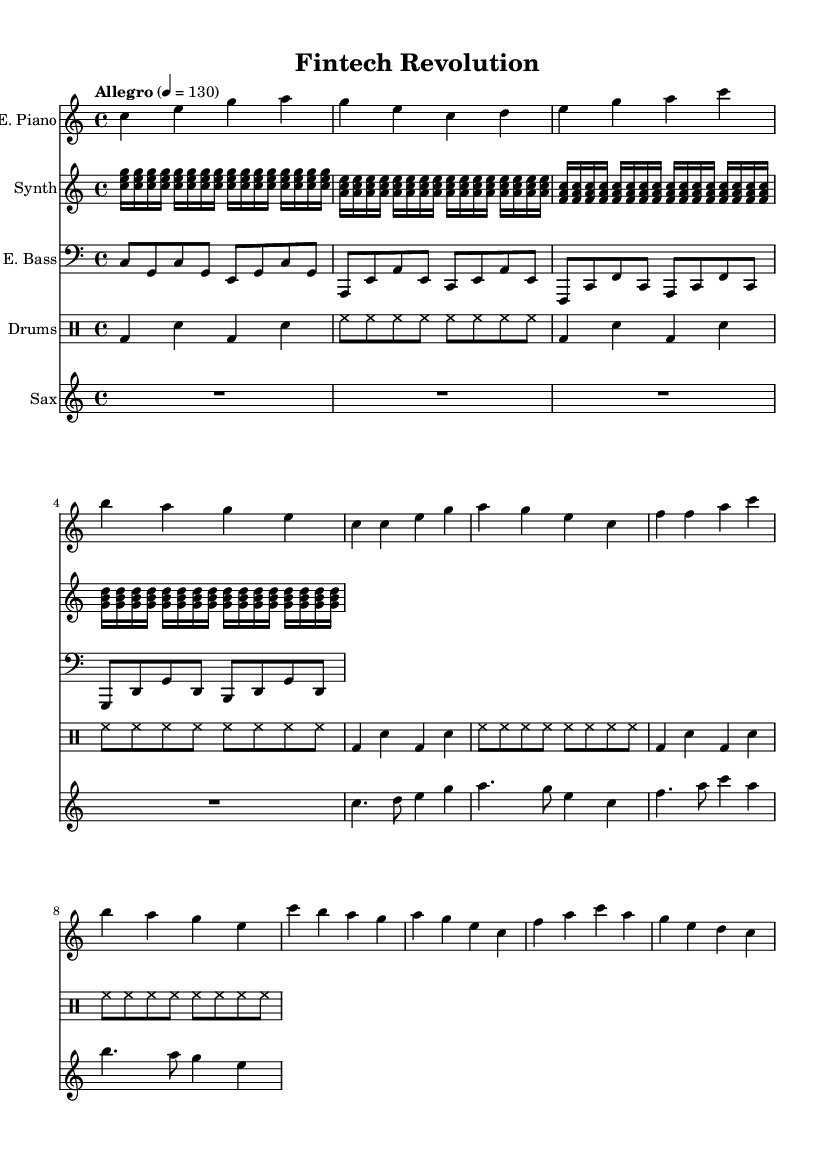What is the key signature of this music? The key signature is indicated at the beginning of the staff, showing C major, which has no sharps or flats.
Answer: C major What is the time signature of this music? The time signature is shown as "4/4", indicating that there are four beats in a measure and the quarter note receives one beat.
Answer: 4/4 What is the tempo marking given for this piece? The tempo marking appears as "Allegro" followed by a metronome marking of 130, indicating a lively and fast pace.
Answer: Allegro, 130 How many measures are there in the electric piano part? By counting the number of vertical lines separating the music sections (bars/logical sections), we find that there are a total of 12 measures for the electric piano.
Answer: 12 Which instrument plays the highest pitch in this score? Analyzing the different staves, the saxophone typically plays in a higher register than the other instruments, indicating it has the highest pitch overall.
Answer: Saxophone What type of rhythm pattern is used in the drum part? The pattern consists of a combination of bass drum hits followed by snare drum and continuous hi-hat hits, which is a common rhythm in electronic and jazz music.
Answer: Syncopated How many distinct musical sections are in the synthesizer part? The synthesizer part contains distinct repeating sections organized in groups of four, totaling four unique chords that repeat, which reveals its structured design.
Answer: 4 